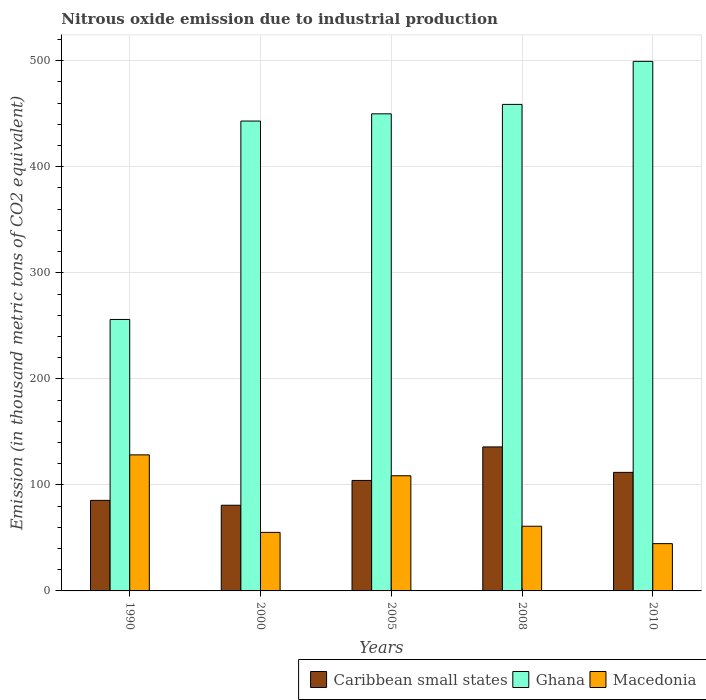How many different coloured bars are there?
Make the answer very short. 3. How many groups of bars are there?
Make the answer very short. 5. Are the number of bars per tick equal to the number of legend labels?
Offer a terse response. Yes. Are the number of bars on each tick of the X-axis equal?
Your response must be concise. Yes. In how many cases, is the number of bars for a given year not equal to the number of legend labels?
Offer a very short reply. 0. What is the amount of nitrous oxide emitted in Caribbean small states in 2008?
Ensure brevity in your answer.  135.8. Across all years, what is the maximum amount of nitrous oxide emitted in Caribbean small states?
Provide a succinct answer. 135.8. Across all years, what is the minimum amount of nitrous oxide emitted in Caribbean small states?
Your response must be concise. 80.8. What is the total amount of nitrous oxide emitted in Macedonia in the graph?
Give a very brief answer. 397.7. What is the difference between the amount of nitrous oxide emitted in Ghana in 2000 and that in 2010?
Give a very brief answer. -56.3. What is the difference between the amount of nitrous oxide emitted in Ghana in 2008 and the amount of nitrous oxide emitted in Caribbean small states in 1990?
Provide a succinct answer. 373.4. What is the average amount of nitrous oxide emitted in Caribbean small states per year?
Give a very brief answer. 103.6. In the year 2005, what is the difference between the amount of nitrous oxide emitted in Ghana and amount of nitrous oxide emitted in Macedonia?
Make the answer very short. 341.3. In how many years, is the amount of nitrous oxide emitted in Caribbean small states greater than 140 thousand metric tons?
Keep it short and to the point. 0. What is the ratio of the amount of nitrous oxide emitted in Caribbean small states in 2008 to that in 2010?
Make the answer very short. 1.21. Is the amount of nitrous oxide emitted in Macedonia in 1990 less than that in 2005?
Provide a short and direct response. No. Is the difference between the amount of nitrous oxide emitted in Ghana in 2000 and 2008 greater than the difference between the amount of nitrous oxide emitted in Macedonia in 2000 and 2008?
Provide a short and direct response. No. What is the difference between the highest and the second highest amount of nitrous oxide emitted in Caribbean small states?
Your answer should be very brief. 24. What is the difference between the highest and the lowest amount of nitrous oxide emitted in Caribbean small states?
Provide a succinct answer. 55. What does the 2nd bar from the left in 2005 represents?
Make the answer very short. Ghana. What does the 3rd bar from the right in 2008 represents?
Provide a short and direct response. Caribbean small states. Is it the case that in every year, the sum of the amount of nitrous oxide emitted in Ghana and amount of nitrous oxide emitted in Macedonia is greater than the amount of nitrous oxide emitted in Caribbean small states?
Provide a succinct answer. Yes. How many bars are there?
Your response must be concise. 15. Are all the bars in the graph horizontal?
Keep it short and to the point. No. How many years are there in the graph?
Your answer should be compact. 5. Does the graph contain any zero values?
Make the answer very short. No. Does the graph contain grids?
Offer a very short reply. Yes. Where does the legend appear in the graph?
Make the answer very short. Bottom right. How many legend labels are there?
Give a very brief answer. 3. What is the title of the graph?
Make the answer very short. Nitrous oxide emission due to industrial production. What is the label or title of the Y-axis?
Your response must be concise. Emission (in thousand metric tons of CO2 equivalent). What is the Emission (in thousand metric tons of CO2 equivalent) in Caribbean small states in 1990?
Offer a terse response. 85.4. What is the Emission (in thousand metric tons of CO2 equivalent) in Ghana in 1990?
Your answer should be compact. 256. What is the Emission (in thousand metric tons of CO2 equivalent) of Macedonia in 1990?
Make the answer very short. 128.3. What is the Emission (in thousand metric tons of CO2 equivalent) of Caribbean small states in 2000?
Provide a short and direct response. 80.8. What is the Emission (in thousand metric tons of CO2 equivalent) of Ghana in 2000?
Keep it short and to the point. 443.1. What is the Emission (in thousand metric tons of CO2 equivalent) in Macedonia in 2000?
Give a very brief answer. 55.2. What is the Emission (in thousand metric tons of CO2 equivalent) of Caribbean small states in 2005?
Ensure brevity in your answer.  104.2. What is the Emission (in thousand metric tons of CO2 equivalent) of Ghana in 2005?
Ensure brevity in your answer.  449.9. What is the Emission (in thousand metric tons of CO2 equivalent) of Macedonia in 2005?
Ensure brevity in your answer.  108.6. What is the Emission (in thousand metric tons of CO2 equivalent) of Caribbean small states in 2008?
Provide a succinct answer. 135.8. What is the Emission (in thousand metric tons of CO2 equivalent) in Ghana in 2008?
Offer a very short reply. 458.8. What is the Emission (in thousand metric tons of CO2 equivalent) of Caribbean small states in 2010?
Offer a very short reply. 111.8. What is the Emission (in thousand metric tons of CO2 equivalent) in Ghana in 2010?
Offer a very short reply. 499.4. What is the Emission (in thousand metric tons of CO2 equivalent) in Macedonia in 2010?
Make the answer very short. 44.6. Across all years, what is the maximum Emission (in thousand metric tons of CO2 equivalent) of Caribbean small states?
Your answer should be very brief. 135.8. Across all years, what is the maximum Emission (in thousand metric tons of CO2 equivalent) in Ghana?
Give a very brief answer. 499.4. Across all years, what is the maximum Emission (in thousand metric tons of CO2 equivalent) in Macedonia?
Give a very brief answer. 128.3. Across all years, what is the minimum Emission (in thousand metric tons of CO2 equivalent) in Caribbean small states?
Your response must be concise. 80.8. Across all years, what is the minimum Emission (in thousand metric tons of CO2 equivalent) in Ghana?
Provide a succinct answer. 256. Across all years, what is the minimum Emission (in thousand metric tons of CO2 equivalent) in Macedonia?
Make the answer very short. 44.6. What is the total Emission (in thousand metric tons of CO2 equivalent) of Caribbean small states in the graph?
Offer a terse response. 518. What is the total Emission (in thousand metric tons of CO2 equivalent) of Ghana in the graph?
Make the answer very short. 2107.2. What is the total Emission (in thousand metric tons of CO2 equivalent) in Macedonia in the graph?
Offer a very short reply. 397.7. What is the difference between the Emission (in thousand metric tons of CO2 equivalent) of Ghana in 1990 and that in 2000?
Give a very brief answer. -187.1. What is the difference between the Emission (in thousand metric tons of CO2 equivalent) in Macedonia in 1990 and that in 2000?
Ensure brevity in your answer.  73.1. What is the difference between the Emission (in thousand metric tons of CO2 equivalent) in Caribbean small states in 1990 and that in 2005?
Provide a succinct answer. -18.8. What is the difference between the Emission (in thousand metric tons of CO2 equivalent) in Ghana in 1990 and that in 2005?
Your response must be concise. -193.9. What is the difference between the Emission (in thousand metric tons of CO2 equivalent) of Macedonia in 1990 and that in 2005?
Provide a succinct answer. 19.7. What is the difference between the Emission (in thousand metric tons of CO2 equivalent) in Caribbean small states in 1990 and that in 2008?
Ensure brevity in your answer.  -50.4. What is the difference between the Emission (in thousand metric tons of CO2 equivalent) of Ghana in 1990 and that in 2008?
Ensure brevity in your answer.  -202.8. What is the difference between the Emission (in thousand metric tons of CO2 equivalent) of Macedonia in 1990 and that in 2008?
Provide a short and direct response. 67.3. What is the difference between the Emission (in thousand metric tons of CO2 equivalent) in Caribbean small states in 1990 and that in 2010?
Give a very brief answer. -26.4. What is the difference between the Emission (in thousand metric tons of CO2 equivalent) of Ghana in 1990 and that in 2010?
Give a very brief answer. -243.4. What is the difference between the Emission (in thousand metric tons of CO2 equivalent) of Macedonia in 1990 and that in 2010?
Provide a short and direct response. 83.7. What is the difference between the Emission (in thousand metric tons of CO2 equivalent) in Caribbean small states in 2000 and that in 2005?
Offer a terse response. -23.4. What is the difference between the Emission (in thousand metric tons of CO2 equivalent) of Ghana in 2000 and that in 2005?
Offer a very short reply. -6.8. What is the difference between the Emission (in thousand metric tons of CO2 equivalent) in Macedonia in 2000 and that in 2005?
Your answer should be compact. -53.4. What is the difference between the Emission (in thousand metric tons of CO2 equivalent) in Caribbean small states in 2000 and that in 2008?
Provide a succinct answer. -55. What is the difference between the Emission (in thousand metric tons of CO2 equivalent) in Ghana in 2000 and that in 2008?
Provide a succinct answer. -15.7. What is the difference between the Emission (in thousand metric tons of CO2 equivalent) of Macedonia in 2000 and that in 2008?
Provide a succinct answer. -5.8. What is the difference between the Emission (in thousand metric tons of CO2 equivalent) of Caribbean small states in 2000 and that in 2010?
Provide a succinct answer. -31. What is the difference between the Emission (in thousand metric tons of CO2 equivalent) of Ghana in 2000 and that in 2010?
Ensure brevity in your answer.  -56.3. What is the difference between the Emission (in thousand metric tons of CO2 equivalent) in Macedonia in 2000 and that in 2010?
Your answer should be very brief. 10.6. What is the difference between the Emission (in thousand metric tons of CO2 equivalent) of Caribbean small states in 2005 and that in 2008?
Your response must be concise. -31.6. What is the difference between the Emission (in thousand metric tons of CO2 equivalent) of Ghana in 2005 and that in 2008?
Your answer should be very brief. -8.9. What is the difference between the Emission (in thousand metric tons of CO2 equivalent) of Macedonia in 2005 and that in 2008?
Your response must be concise. 47.6. What is the difference between the Emission (in thousand metric tons of CO2 equivalent) in Caribbean small states in 2005 and that in 2010?
Your response must be concise. -7.6. What is the difference between the Emission (in thousand metric tons of CO2 equivalent) of Ghana in 2005 and that in 2010?
Offer a very short reply. -49.5. What is the difference between the Emission (in thousand metric tons of CO2 equivalent) of Ghana in 2008 and that in 2010?
Keep it short and to the point. -40.6. What is the difference between the Emission (in thousand metric tons of CO2 equivalent) of Caribbean small states in 1990 and the Emission (in thousand metric tons of CO2 equivalent) of Ghana in 2000?
Your response must be concise. -357.7. What is the difference between the Emission (in thousand metric tons of CO2 equivalent) of Caribbean small states in 1990 and the Emission (in thousand metric tons of CO2 equivalent) of Macedonia in 2000?
Provide a short and direct response. 30.2. What is the difference between the Emission (in thousand metric tons of CO2 equivalent) in Ghana in 1990 and the Emission (in thousand metric tons of CO2 equivalent) in Macedonia in 2000?
Keep it short and to the point. 200.8. What is the difference between the Emission (in thousand metric tons of CO2 equivalent) of Caribbean small states in 1990 and the Emission (in thousand metric tons of CO2 equivalent) of Ghana in 2005?
Provide a succinct answer. -364.5. What is the difference between the Emission (in thousand metric tons of CO2 equivalent) of Caribbean small states in 1990 and the Emission (in thousand metric tons of CO2 equivalent) of Macedonia in 2005?
Your answer should be very brief. -23.2. What is the difference between the Emission (in thousand metric tons of CO2 equivalent) in Ghana in 1990 and the Emission (in thousand metric tons of CO2 equivalent) in Macedonia in 2005?
Your response must be concise. 147.4. What is the difference between the Emission (in thousand metric tons of CO2 equivalent) in Caribbean small states in 1990 and the Emission (in thousand metric tons of CO2 equivalent) in Ghana in 2008?
Provide a short and direct response. -373.4. What is the difference between the Emission (in thousand metric tons of CO2 equivalent) in Caribbean small states in 1990 and the Emission (in thousand metric tons of CO2 equivalent) in Macedonia in 2008?
Make the answer very short. 24.4. What is the difference between the Emission (in thousand metric tons of CO2 equivalent) of Ghana in 1990 and the Emission (in thousand metric tons of CO2 equivalent) of Macedonia in 2008?
Provide a short and direct response. 195. What is the difference between the Emission (in thousand metric tons of CO2 equivalent) of Caribbean small states in 1990 and the Emission (in thousand metric tons of CO2 equivalent) of Ghana in 2010?
Offer a very short reply. -414. What is the difference between the Emission (in thousand metric tons of CO2 equivalent) of Caribbean small states in 1990 and the Emission (in thousand metric tons of CO2 equivalent) of Macedonia in 2010?
Keep it short and to the point. 40.8. What is the difference between the Emission (in thousand metric tons of CO2 equivalent) in Ghana in 1990 and the Emission (in thousand metric tons of CO2 equivalent) in Macedonia in 2010?
Your answer should be very brief. 211.4. What is the difference between the Emission (in thousand metric tons of CO2 equivalent) in Caribbean small states in 2000 and the Emission (in thousand metric tons of CO2 equivalent) in Ghana in 2005?
Offer a terse response. -369.1. What is the difference between the Emission (in thousand metric tons of CO2 equivalent) of Caribbean small states in 2000 and the Emission (in thousand metric tons of CO2 equivalent) of Macedonia in 2005?
Make the answer very short. -27.8. What is the difference between the Emission (in thousand metric tons of CO2 equivalent) of Ghana in 2000 and the Emission (in thousand metric tons of CO2 equivalent) of Macedonia in 2005?
Ensure brevity in your answer.  334.5. What is the difference between the Emission (in thousand metric tons of CO2 equivalent) of Caribbean small states in 2000 and the Emission (in thousand metric tons of CO2 equivalent) of Ghana in 2008?
Make the answer very short. -378. What is the difference between the Emission (in thousand metric tons of CO2 equivalent) of Caribbean small states in 2000 and the Emission (in thousand metric tons of CO2 equivalent) of Macedonia in 2008?
Offer a very short reply. 19.8. What is the difference between the Emission (in thousand metric tons of CO2 equivalent) of Ghana in 2000 and the Emission (in thousand metric tons of CO2 equivalent) of Macedonia in 2008?
Provide a short and direct response. 382.1. What is the difference between the Emission (in thousand metric tons of CO2 equivalent) in Caribbean small states in 2000 and the Emission (in thousand metric tons of CO2 equivalent) in Ghana in 2010?
Provide a succinct answer. -418.6. What is the difference between the Emission (in thousand metric tons of CO2 equivalent) of Caribbean small states in 2000 and the Emission (in thousand metric tons of CO2 equivalent) of Macedonia in 2010?
Provide a short and direct response. 36.2. What is the difference between the Emission (in thousand metric tons of CO2 equivalent) in Ghana in 2000 and the Emission (in thousand metric tons of CO2 equivalent) in Macedonia in 2010?
Your answer should be very brief. 398.5. What is the difference between the Emission (in thousand metric tons of CO2 equivalent) in Caribbean small states in 2005 and the Emission (in thousand metric tons of CO2 equivalent) in Ghana in 2008?
Offer a very short reply. -354.6. What is the difference between the Emission (in thousand metric tons of CO2 equivalent) of Caribbean small states in 2005 and the Emission (in thousand metric tons of CO2 equivalent) of Macedonia in 2008?
Offer a very short reply. 43.2. What is the difference between the Emission (in thousand metric tons of CO2 equivalent) of Ghana in 2005 and the Emission (in thousand metric tons of CO2 equivalent) of Macedonia in 2008?
Offer a terse response. 388.9. What is the difference between the Emission (in thousand metric tons of CO2 equivalent) in Caribbean small states in 2005 and the Emission (in thousand metric tons of CO2 equivalent) in Ghana in 2010?
Provide a succinct answer. -395.2. What is the difference between the Emission (in thousand metric tons of CO2 equivalent) of Caribbean small states in 2005 and the Emission (in thousand metric tons of CO2 equivalent) of Macedonia in 2010?
Keep it short and to the point. 59.6. What is the difference between the Emission (in thousand metric tons of CO2 equivalent) in Ghana in 2005 and the Emission (in thousand metric tons of CO2 equivalent) in Macedonia in 2010?
Ensure brevity in your answer.  405.3. What is the difference between the Emission (in thousand metric tons of CO2 equivalent) in Caribbean small states in 2008 and the Emission (in thousand metric tons of CO2 equivalent) in Ghana in 2010?
Your response must be concise. -363.6. What is the difference between the Emission (in thousand metric tons of CO2 equivalent) in Caribbean small states in 2008 and the Emission (in thousand metric tons of CO2 equivalent) in Macedonia in 2010?
Your response must be concise. 91.2. What is the difference between the Emission (in thousand metric tons of CO2 equivalent) of Ghana in 2008 and the Emission (in thousand metric tons of CO2 equivalent) of Macedonia in 2010?
Provide a succinct answer. 414.2. What is the average Emission (in thousand metric tons of CO2 equivalent) in Caribbean small states per year?
Offer a terse response. 103.6. What is the average Emission (in thousand metric tons of CO2 equivalent) in Ghana per year?
Keep it short and to the point. 421.44. What is the average Emission (in thousand metric tons of CO2 equivalent) in Macedonia per year?
Make the answer very short. 79.54. In the year 1990, what is the difference between the Emission (in thousand metric tons of CO2 equivalent) of Caribbean small states and Emission (in thousand metric tons of CO2 equivalent) of Ghana?
Your answer should be compact. -170.6. In the year 1990, what is the difference between the Emission (in thousand metric tons of CO2 equivalent) in Caribbean small states and Emission (in thousand metric tons of CO2 equivalent) in Macedonia?
Ensure brevity in your answer.  -42.9. In the year 1990, what is the difference between the Emission (in thousand metric tons of CO2 equivalent) in Ghana and Emission (in thousand metric tons of CO2 equivalent) in Macedonia?
Your answer should be compact. 127.7. In the year 2000, what is the difference between the Emission (in thousand metric tons of CO2 equivalent) in Caribbean small states and Emission (in thousand metric tons of CO2 equivalent) in Ghana?
Your response must be concise. -362.3. In the year 2000, what is the difference between the Emission (in thousand metric tons of CO2 equivalent) of Caribbean small states and Emission (in thousand metric tons of CO2 equivalent) of Macedonia?
Your response must be concise. 25.6. In the year 2000, what is the difference between the Emission (in thousand metric tons of CO2 equivalent) of Ghana and Emission (in thousand metric tons of CO2 equivalent) of Macedonia?
Offer a terse response. 387.9. In the year 2005, what is the difference between the Emission (in thousand metric tons of CO2 equivalent) in Caribbean small states and Emission (in thousand metric tons of CO2 equivalent) in Ghana?
Your response must be concise. -345.7. In the year 2005, what is the difference between the Emission (in thousand metric tons of CO2 equivalent) of Ghana and Emission (in thousand metric tons of CO2 equivalent) of Macedonia?
Offer a very short reply. 341.3. In the year 2008, what is the difference between the Emission (in thousand metric tons of CO2 equivalent) in Caribbean small states and Emission (in thousand metric tons of CO2 equivalent) in Ghana?
Provide a short and direct response. -323. In the year 2008, what is the difference between the Emission (in thousand metric tons of CO2 equivalent) in Caribbean small states and Emission (in thousand metric tons of CO2 equivalent) in Macedonia?
Provide a short and direct response. 74.8. In the year 2008, what is the difference between the Emission (in thousand metric tons of CO2 equivalent) of Ghana and Emission (in thousand metric tons of CO2 equivalent) of Macedonia?
Give a very brief answer. 397.8. In the year 2010, what is the difference between the Emission (in thousand metric tons of CO2 equivalent) in Caribbean small states and Emission (in thousand metric tons of CO2 equivalent) in Ghana?
Make the answer very short. -387.6. In the year 2010, what is the difference between the Emission (in thousand metric tons of CO2 equivalent) in Caribbean small states and Emission (in thousand metric tons of CO2 equivalent) in Macedonia?
Your response must be concise. 67.2. In the year 2010, what is the difference between the Emission (in thousand metric tons of CO2 equivalent) of Ghana and Emission (in thousand metric tons of CO2 equivalent) of Macedonia?
Your answer should be very brief. 454.8. What is the ratio of the Emission (in thousand metric tons of CO2 equivalent) of Caribbean small states in 1990 to that in 2000?
Ensure brevity in your answer.  1.06. What is the ratio of the Emission (in thousand metric tons of CO2 equivalent) in Ghana in 1990 to that in 2000?
Keep it short and to the point. 0.58. What is the ratio of the Emission (in thousand metric tons of CO2 equivalent) in Macedonia in 1990 to that in 2000?
Offer a very short reply. 2.32. What is the ratio of the Emission (in thousand metric tons of CO2 equivalent) of Caribbean small states in 1990 to that in 2005?
Provide a succinct answer. 0.82. What is the ratio of the Emission (in thousand metric tons of CO2 equivalent) in Ghana in 1990 to that in 2005?
Your answer should be very brief. 0.57. What is the ratio of the Emission (in thousand metric tons of CO2 equivalent) in Macedonia in 1990 to that in 2005?
Make the answer very short. 1.18. What is the ratio of the Emission (in thousand metric tons of CO2 equivalent) in Caribbean small states in 1990 to that in 2008?
Your answer should be compact. 0.63. What is the ratio of the Emission (in thousand metric tons of CO2 equivalent) of Ghana in 1990 to that in 2008?
Make the answer very short. 0.56. What is the ratio of the Emission (in thousand metric tons of CO2 equivalent) of Macedonia in 1990 to that in 2008?
Offer a terse response. 2.1. What is the ratio of the Emission (in thousand metric tons of CO2 equivalent) of Caribbean small states in 1990 to that in 2010?
Your response must be concise. 0.76. What is the ratio of the Emission (in thousand metric tons of CO2 equivalent) in Ghana in 1990 to that in 2010?
Your answer should be compact. 0.51. What is the ratio of the Emission (in thousand metric tons of CO2 equivalent) in Macedonia in 1990 to that in 2010?
Offer a terse response. 2.88. What is the ratio of the Emission (in thousand metric tons of CO2 equivalent) in Caribbean small states in 2000 to that in 2005?
Make the answer very short. 0.78. What is the ratio of the Emission (in thousand metric tons of CO2 equivalent) in Ghana in 2000 to that in 2005?
Offer a very short reply. 0.98. What is the ratio of the Emission (in thousand metric tons of CO2 equivalent) in Macedonia in 2000 to that in 2005?
Keep it short and to the point. 0.51. What is the ratio of the Emission (in thousand metric tons of CO2 equivalent) of Caribbean small states in 2000 to that in 2008?
Your response must be concise. 0.59. What is the ratio of the Emission (in thousand metric tons of CO2 equivalent) of Ghana in 2000 to that in 2008?
Keep it short and to the point. 0.97. What is the ratio of the Emission (in thousand metric tons of CO2 equivalent) in Macedonia in 2000 to that in 2008?
Provide a succinct answer. 0.9. What is the ratio of the Emission (in thousand metric tons of CO2 equivalent) of Caribbean small states in 2000 to that in 2010?
Make the answer very short. 0.72. What is the ratio of the Emission (in thousand metric tons of CO2 equivalent) of Ghana in 2000 to that in 2010?
Give a very brief answer. 0.89. What is the ratio of the Emission (in thousand metric tons of CO2 equivalent) in Macedonia in 2000 to that in 2010?
Give a very brief answer. 1.24. What is the ratio of the Emission (in thousand metric tons of CO2 equivalent) of Caribbean small states in 2005 to that in 2008?
Make the answer very short. 0.77. What is the ratio of the Emission (in thousand metric tons of CO2 equivalent) of Ghana in 2005 to that in 2008?
Ensure brevity in your answer.  0.98. What is the ratio of the Emission (in thousand metric tons of CO2 equivalent) of Macedonia in 2005 to that in 2008?
Offer a very short reply. 1.78. What is the ratio of the Emission (in thousand metric tons of CO2 equivalent) in Caribbean small states in 2005 to that in 2010?
Provide a short and direct response. 0.93. What is the ratio of the Emission (in thousand metric tons of CO2 equivalent) in Ghana in 2005 to that in 2010?
Provide a succinct answer. 0.9. What is the ratio of the Emission (in thousand metric tons of CO2 equivalent) of Macedonia in 2005 to that in 2010?
Your answer should be compact. 2.44. What is the ratio of the Emission (in thousand metric tons of CO2 equivalent) in Caribbean small states in 2008 to that in 2010?
Make the answer very short. 1.21. What is the ratio of the Emission (in thousand metric tons of CO2 equivalent) in Ghana in 2008 to that in 2010?
Provide a short and direct response. 0.92. What is the ratio of the Emission (in thousand metric tons of CO2 equivalent) in Macedonia in 2008 to that in 2010?
Your response must be concise. 1.37. What is the difference between the highest and the second highest Emission (in thousand metric tons of CO2 equivalent) of Caribbean small states?
Make the answer very short. 24. What is the difference between the highest and the second highest Emission (in thousand metric tons of CO2 equivalent) in Ghana?
Make the answer very short. 40.6. What is the difference between the highest and the second highest Emission (in thousand metric tons of CO2 equivalent) in Macedonia?
Give a very brief answer. 19.7. What is the difference between the highest and the lowest Emission (in thousand metric tons of CO2 equivalent) of Caribbean small states?
Make the answer very short. 55. What is the difference between the highest and the lowest Emission (in thousand metric tons of CO2 equivalent) of Ghana?
Keep it short and to the point. 243.4. What is the difference between the highest and the lowest Emission (in thousand metric tons of CO2 equivalent) of Macedonia?
Your answer should be compact. 83.7. 